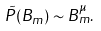Convert formula to latex. <formula><loc_0><loc_0><loc_500><loc_500>\tilde { P } ( B _ { m } ) \sim B _ { m } ^ { \mu } .</formula> 